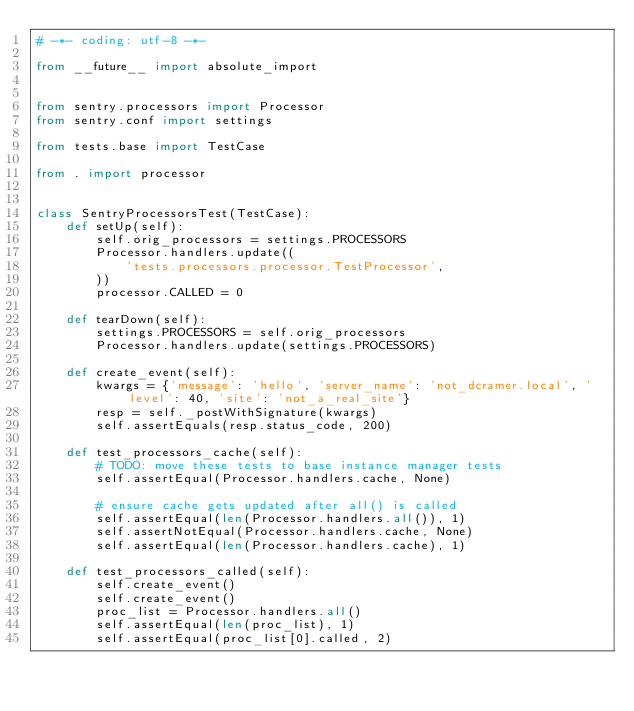Convert code to text. <code><loc_0><loc_0><loc_500><loc_500><_Python_># -*- coding: utf-8 -*-

from __future__ import absolute_import


from sentry.processors import Processor
from sentry.conf import settings

from tests.base import TestCase

from . import processor


class SentryProcessorsTest(TestCase):
    def setUp(self):
        self.orig_processors = settings.PROCESSORS
        Processor.handlers.update((
            'tests.processors.processor.TestProcessor',
        ))
        processor.CALLED = 0

    def tearDown(self):
        settings.PROCESSORS = self.orig_processors
        Processor.handlers.update(settings.PROCESSORS)

    def create_event(self):
        kwargs = {'message': 'hello', 'server_name': 'not_dcramer.local', 'level': 40, 'site': 'not_a_real_site'}
        resp = self._postWithSignature(kwargs)
        self.assertEquals(resp.status_code, 200)

    def test_processors_cache(self):
        # TODO: move these tests to base instance manager tests
        self.assertEqual(Processor.handlers.cache, None)

        # ensure cache gets updated after all() is called
        self.assertEqual(len(Processor.handlers.all()), 1)
        self.assertNotEqual(Processor.handlers.cache, None)
        self.assertEqual(len(Processor.handlers.cache), 1)

    def test_processors_called(self):
        self.create_event()
        self.create_event()
        proc_list = Processor.handlers.all()
        self.assertEqual(len(proc_list), 1)
        self.assertEqual(proc_list[0].called, 2)
</code> 